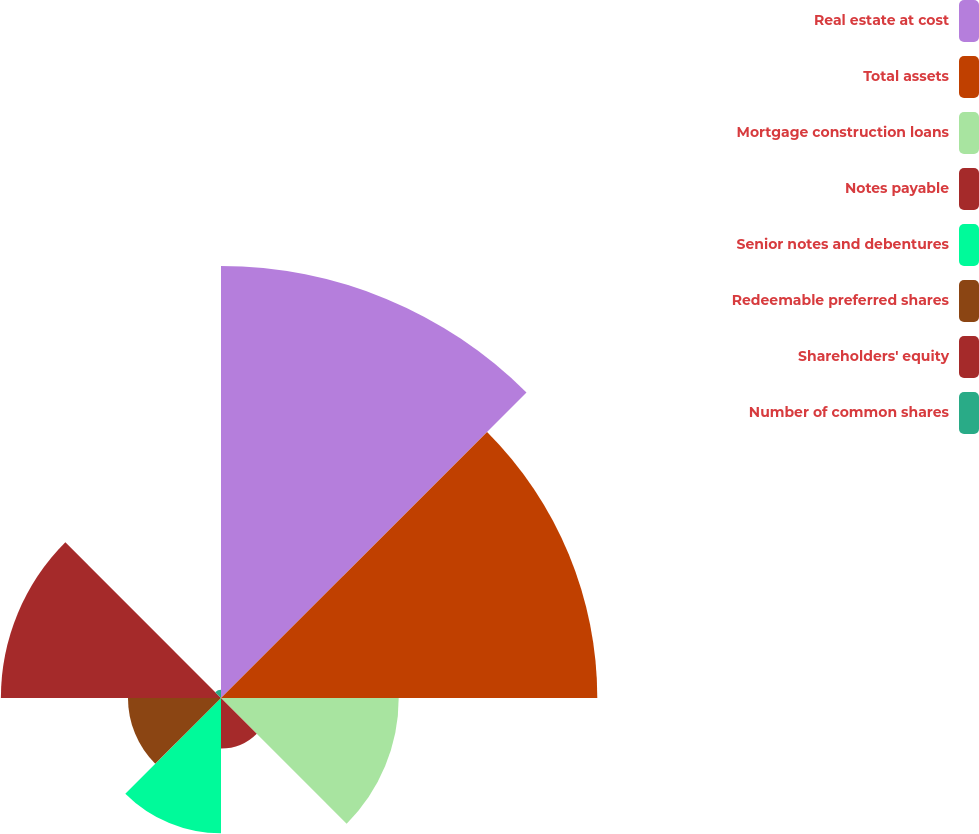Convert chart to OTSL. <chart><loc_0><loc_0><loc_500><loc_500><pie_chart><fcel>Real estate at cost<fcel>Total assets<fcel>Mortgage construction loans<fcel>Notes payable<fcel>Senior notes and debentures<fcel>Redeemable preferred shares<fcel>Shareholders' equity<fcel>Number of common shares<nl><fcel>28.93%<fcel>25.2%<fcel>11.9%<fcel>3.39%<fcel>9.06%<fcel>6.23%<fcel>14.74%<fcel>0.55%<nl></chart> 